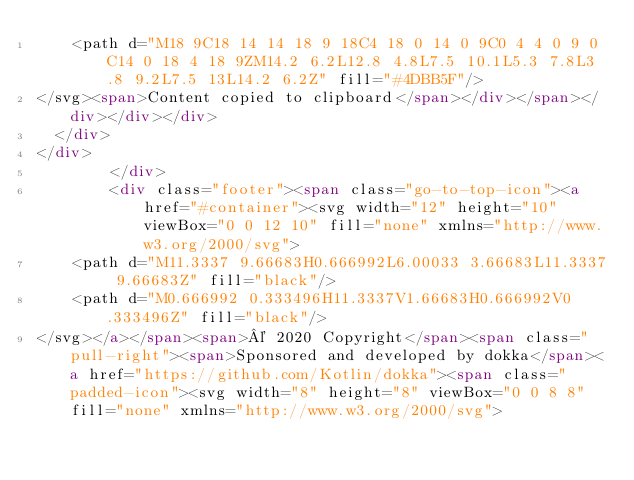Convert code to text. <code><loc_0><loc_0><loc_500><loc_500><_HTML_>    <path d="M18 9C18 14 14 18 9 18C4 18 0 14 0 9C0 4 4 0 9 0C14 0 18 4 18 9ZM14.2 6.2L12.8 4.8L7.5 10.1L5.3 7.8L3.8 9.2L7.5 13L14.2 6.2Z" fill="#4DBB5F"/>
</svg><span>Content copied to clipboard</span></div></span></div></div></div>
  </div>
</div>
        </div>
        <div class="footer"><span class="go-to-top-icon"><a href="#container"><svg width="12" height="10" viewBox="0 0 12 10" fill="none" xmlns="http://www.w3.org/2000/svg">
    <path d="M11.3337 9.66683H0.666992L6.00033 3.66683L11.3337 9.66683Z" fill="black"/>
    <path d="M0.666992 0.333496H11.3337V1.66683H0.666992V0.333496Z" fill="black"/>
</svg></a></span><span>© 2020 Copyright</span><span class="pull-right"><span>Sponsored and developed by dokka</span><a href="https://github.com/Kotlin/dokka"><span class="padded-icon"><svg width="8" height="8" viewBox="0 0 8 8" fill="none" xmlns="http://www.w3.org/2000/svg"></code> 